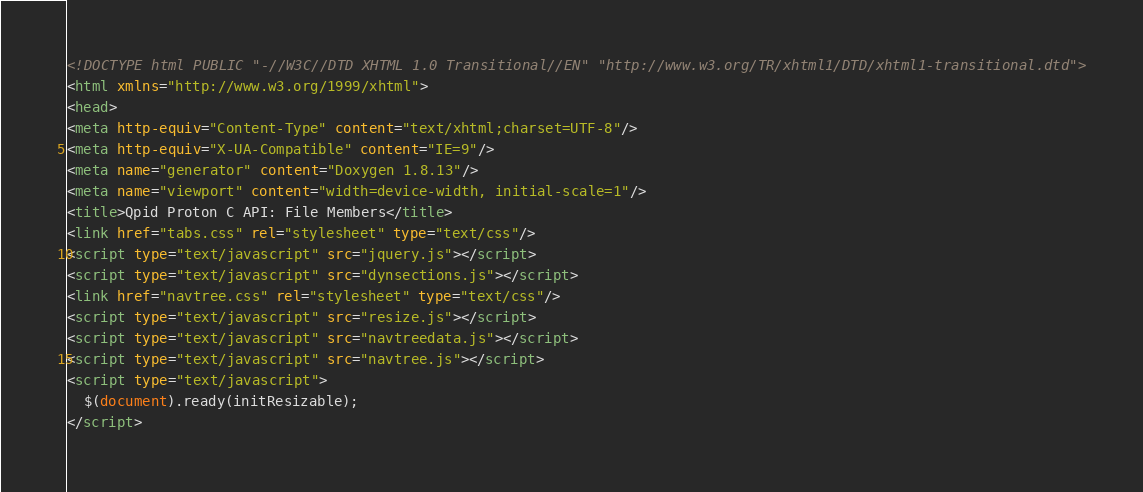Convert code to text. <code><loc_0><loc_0><loc_500><loc_500><_HTML_><!DOCTYPE html PUBLIC "-//W3C//DTD XHTML 1.0 Transitional//EN" "http://www.w3.org/TR/xhtml1/DTD/xhtml1-transitional.dtd">
<html xmlns="http://www.w3.org/1999/xhtml">
<head>
<meta http-equiv="Content-Type" content="text/xhtml;charset=UTF-8"/>
<meta http-equiv="X-UA-Compatible" content="IE=9"/>
<meta name="generator" content="Doxygen 1.8.13"/>
<meta name="viewport" content="width=device-width, initial-scale=1"/>
<title>Qpid Proton C API: File Members</title>
<link href="tabs.css" rel="stylesheet" type="text/css"/>
<script type="text/javascript" src="jquery.js"></script>
<script type="text/javascript" src="dynsections.js"></script>
<link href="navtree.css" rel="stylesheet" type="text/css"/>
<script type="text/javascript" src="resize.js"></script>
<script type="text/javascript" src="navtreedata.js"></script>
<script type="text/javascript" src="navtree.js"></script>
<script type="text/javascript">
  $(document).ready(initResizable);
</script></code> 